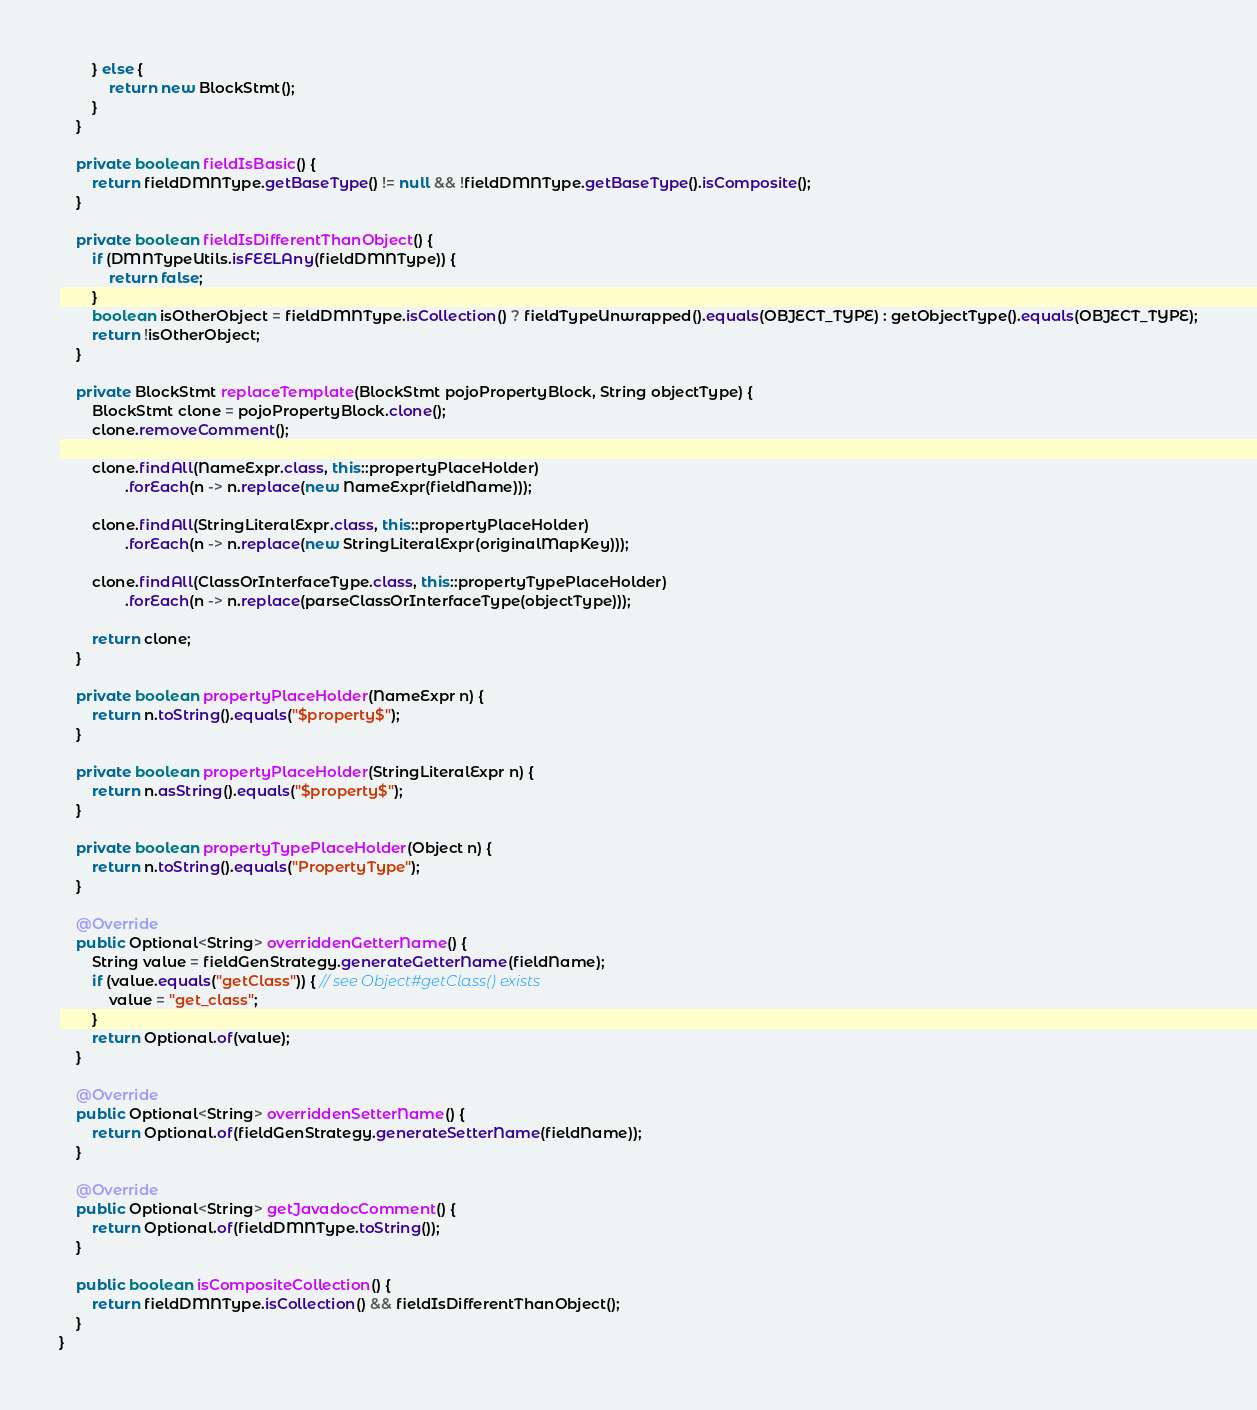<code> <loc_0><loc_0><loc_500><loc_500><_Java_>        } else {
            return new BlockStmt();
        }
    }

    private boolean fieldIsBasic() {
        return fieldDMNType.getBaseType() != null && !fieldDMNType.getBaseType().isComposite();
    }

    private boolean fieldIsDifferentThanObject() {
        if (DMNTypeUtils.isFEELAny(fieldDMNType)) {
            return false;
        }
        boolean isOtherObject = fieldDMNType.isCollection() ? fieldTypeUnwrapped().equals(OBJECT_TYPE) : getObjectType().equals(OBJECT_TYPE);
        return !isOtherObject;
    }

    private BlockStmt replaceTemplate(BlockStmt pojoPropertyBlock, String objectType) {
        BlockStmt clone = pojoPropertyBlock.clone();
        clone.removeComment();

        clone.findAll(NameExpr.class, this::propertyPlaceHolder)
                .forEach(n -> n.replace(new NameExpr(fieldName)));

        clone.findAll(StringLiteralExpr.class, this::propertyPlaceHolder)
                .forEach(n -> n.replace(new StringLiteralExpr(originalMapKey)));

        clone.findAll(ClassOrInterfaceType.class, this::propertyTypePlaceHolder)
                .forEach(n -> n.replace(parseClassOrInterfaceType(objectType)));

        return clone;
    }

    private boolean propertyPlaceHolder(NameExpr n) {
        return n.toString().equals("$property$");
    }

    private boolean propertyPlaceHolder(StringLiteralExpr n) {
        return n.asString().equals("$property$");
    }

    private boolean propertyTypePlaceHolder(Object n) {
        return n.toString().equals("PropertyType");
    }

    @Override
    public Optional<String> overriddenGetterName() {
        String value = fieldGenStrategy.generateGetterName(fieldName);
        if (value.equals("getClass")) { // see Object#getClass() exists
            value = "get_class";
        }
        return Optional.of(value);
    }

    @Override
    public Optional<String> overriddenSetterName() {
        return Optional.of(fieldGenStrategy.generateSetterName(fieldName));
    }

    @Override
    public Optional<String> getJavadocComment() {
        return Optional.of(fieldDMNType.toString());
    }

    public boolean isCompositeCollection() {
        return fieldDMNType.isCollection() && fieldIsDifferentThanObject();
    }
}
</code> 